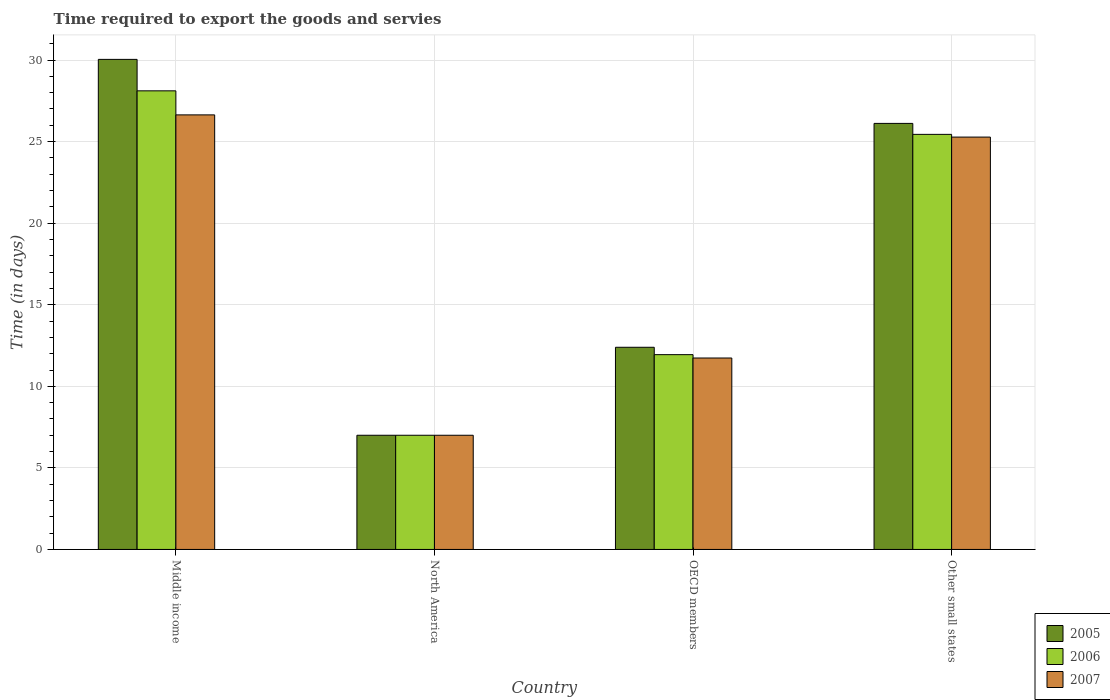Are the number of bars per tick equal to the number of legend labels?
Provide a short and direct response. Yes. How many bars are there on the 1st tick from the left?
Keep it short and to the point. 3. What is the label of the 4th group of bars from the left?
Keep it short and to the point. Other small states. In how many cases, is the number of bars for a given country not equal to the number of legend labels?
Provide a succinct answer. 0. What is the number of days required to export the goods and services in 2005 in Other small states?
Offer a very short reply. 26.12. Across all countries, what is the maximum number of days required to export the goods and services in 2007?
Provide a short and direct response. 26.64. Across all countries, what is the minimum number of days required to export the goods and services in 2005?
Keep it short and to the point. 7. In which country was the number of days required to export the goods and services in 2005 maximum?
Make the answer very short. Middle income. In which country was the number of days required to export the goods and services in 2007 minimum?
Offer a terse response. North America. What is the total number of days required to export the goods and services in 2005 in the graph?
Your answer should be compact. 75.55. What is the difference between the number of days required to export the goods and services in 2005 in Middle income and that in North America?
Give a very brief answer. 23.04. What is the difference between the number of days required to export the goods and services in 2005 in North America and the number of days required to export the goods and services in 2007 in Other small states?
Provide a short and direct response. -18.28. What is the average number of days required to export the goods and services in 2005 per country?
Provide a succinct answer. 18.89. What is the difference between the number of days required to export the goods and services of/in 2005 and number of days required to export the goods and services of/in 2007 in OECD members?
Keep it short and to the point. 0.66. What is the ratio of the number of days required to export the goods and services in 2005 in North America to that in Other small states?
Provide a succinct answer. 0.27. Is the number of days required to export the goods and services in 2007 in North America less than that in OECD members?
Provide a short and direct response. Yes. What is the difference between the highest and the second highest number of days required to export the goods and services in 2006?
Provide a succinct answer. 13.5. What is the difference between the highest and the lowest number of days required to export the goods and services in 2006?
Offer a very short reply. 21.11. What does the 3rd bar from the left in OECD members represents?
Make the answer very short. 2007. What does the 1st bar from the right in North America represents?
Your answer should be very brief. 2007. Is it the case that in every country, the sum of the number of days required to export the goods and services in 2006 and number of days required to export the goods and services in 2005 is greater than the number of days required to export the goods and services in 2007?
Offer a terse response. Yes. How many bars are there?
Offer a very short reply. 12. Are all the bars in the graph horizontal?
Your response must be concise. No. How many countries are there in the graph?
Keep it short and to the point. 4. Are the values on the major ticks of Y-axis written in scientific E-notation?
Give a very brief answer. No. What is the title of the graph?
Offer a terse response. Time required to export the goods and servies. What is the label or title of the Y-axis?
Make the answer very short. Time (in days). What is the Time (in days) in 2005 in Middle income?
Provide a short and direct response. 30.04. What is the Time (in days) in 2006 in Middle income?
Give a very brief answer. 28.11. What is the Time (in days) in 2007 in Middle income?
Offer a very short reply. 26.64. What is the Time (in days) in 2007 in North America?
Provide a short and direct response. 7. What is the Time (in days) in 2005 in OECD members?
Your answer should be very brief. 12.39. What is the Time (in days) in 2006 in OECD members?
Offer a terse response. 11.94. What is the Time (in days) of 2007 in OECD members?
Ensure brevity in your answer.  11.74. What is the Time (in days) of 2005 in Other small states?
Give a very brief answer. 26.12. What is the Time (in days) in 2006 in Other small states?
Offer a terse response. 25.44. What is the Time (in days) of 2007 in Other small states?
Your answer should be very brief. 25.28. Across all countries, what is the maximum Time (in days) in 2005?
Ensure brevity in your answer.  30.04. Across all countries, what is the maximum Time (in days) of 2006?
Your answer should be very brief. 28.11. Across all countries, what is the maximum Time (in days) in 2007?
Provide a short and direct response. 26.64. Across all countries, what is the minimum Time (in days) of 2007?
Provide a short and direct response. 7. What is the total Time (in days) in 2005 in the graph?
Give a very brief answer. 75.55. What is the total Time (in days) of 2006 in the graph?
Provide a short and direct response. 72.5. What is the total Time (in days) of 2007 in the graph?
Give a very brief answer. 70.65. What is the difference between the Time (in days) of 2005 in Middle income and that in North America?
Make the answer very short. 23.04. What is the difference between the Time (in days) in 2006 in Middle income and that in North America?
Give a very brief answer. 21.11. What is the difference between the Time (in days) of 2007 in Middle income and that in North America?
Ensure brevity in your answer.  19.64. What is the difference between the Time (in days) in 2005 in Middle income and that in OECD members?
Give a very brief answer. 17.65. What is the difference between the Time (in days) in 2006 in Middle income and that in OECD members?
Offer a very short reply. 16.17. What is the difference between the Time (in days) of 2007 in Middle income and that in OECD members?
Offer a terse response. 14.9. What is the difference between the Time (in days) of 2005 in Middle income and that in Other small states?
Your response must be concise. 3.92. What is the difference between the Time (in days) of 2006 in Middle income and that in Other small states?
Your answer should be compact. 2.67. What is the difference between the Time (in days) of 2007 in Middle income and that in Other small states?
Provide a short and direct response. 1.36. What is the difference between the Time (in days) in 2005 in North America and that in OECD members?
Ensure brevity in your answer.  -5.39. What is the difference between the Time (in days) of 2006 in North America and that in OECD members?
Offer a very short reply. -4.94. What is the difference between the Time (in days) of 2007 in North America and that in OECD members?
Ensure brevity in your answer.  -4.74. What is the difference between the Time (in days) in 2005 in North America and that in Other small states?
Your response must be concise. -19.12. What is the difference between the Time (in days) in 2006 in North America and that in Other small states?
Offer a terse response. -18.44. What is the difference between the Time (in days) in 2007 in North America and that in Other small states?
Make the answer very short. -18.28. What is the difference between the Time (in days) of 2005 in OECD members and that in Other small states?
Make the answer very short. -13.72. What is the difference between the Time (in days) in 2006 in OECD members and that in Other small states?
Ensure brevity in your answer.  -13.5. What is the difference between the Time (in days) of 2007 in OECD members and that in Other small states?
Offer a very short reply. -13.54. What is the difference between the Time (in days) of 2005 in Middle income and the Time (in days) of 2006 in North America?
Offer a very short reply. 23.04. What is the difference between the Time (in days) of 2005 in Middle income and the Time (in days) of 2007 in North America?
Your answer should be compact. 23.04. What is the difference between the Time (in days) in 2006 in Middle income and the Time (in days) in 2007 in North America?
Ensure brevity in your answer.  21.11. What is the difference between the Time (in days) in 2005 in Middle income and the Time (in days) in 2006 in OECD members?
Provide a succinct answer. 18.1. What is the difference between the Time (in days) of 2005 in Middle income and the Time (in days) of 2007 in OECD members?
Offer a very short reply. 18.31. What is the difference between the Time (in days) of 2006 in Middle income and the Time (in days) of 2007 in OECD members?
Provide a succinct answer. 16.38. What is the difference between the Time (in days) of 2005 in Middle income and the Time (in days) of 2006 in Other small states?
Provide a succinct answer. 4.6. What is the difference between the Time (in days) of 2005 in Middle income and the Time (in days) of 2007 in Other small states?
Offer a very short reply. 4.76. What is the difference between the Time (in days) of 2006 in Middle income and the Time (in days) of 2007 in Other small states?
Your response must be concise. 2.84. What is the difference between the Time (in days) of 2005 in North America and the Time (in days) of 2006 in OECD members?
Offer a very short reply. -4.94. What is the difference between the Time (in days) of 2005 in North America and the Time (in days) of 2007 in OECD members?
Give a very brief answer. -4.74. What is the difference between the Time (in days) in 2006 in North America and the Time (in days) in 2007 in OECD members?
Your answer should be very brief. -4.74. What is the difference between the Time (in days) in 2005 in North America and the Time (in days) in 2006 in Other small states?
Offer a terse response. -18.44. What is the difference between the Time (in days) of 2005 in North America and the Time (in days) of 2007 in Other small states?
Offer a very short reply. -18.28. What is the difference between the Time (in days) of 2006 in North America and the Time (in days) of 2007 in Other small states?
Your answer should be compact. -18.28. What is the difference between the Time (in days) in 2005 in OECD members and the Time (in days) in 2006 in Other small states?
Keep it short and to the point. -13.05. What is the difference between the Time (in days) of 2005 in OECD members and the Time (in days) of 2007 in Other small states?
Make the answer very short. -12.88. What is the difference between the Time (in days) of 2006 in OECD members and the Time (in days) of 2007 in Other small states?
Make the answer very short. -13.34. What is the average Time (in days) in 2005 per country?
Provide a short and direct response. 18.89. What is the average Time (in days) in 2006 per country?
Your answer should be very brief. 18.12. What is the average Time (in days) of 2007 per country?
Your response must be concise. 17.66. What is the difference between the Time (in days) of 2005 and Time (in days) of 2006 in Middle income?
Make the answer very short. 1.93. What is the difference between the Time (in days) in 2005 and Time (in days) in 2007 in Middle income?
Your answer should be compact. 3.4. What is the difference between the Time (in days) of 2006 and Time (in days) of 2007 in Middle income?
Your answer should be compact. 1.47. What is the difference between the Time (in days) of 2005 and Time (in days) of 2006 in North America?
Make the answer very short. 0. What is the difference between the Time (in days) in 2005 and Time (in days) in 2007 in North America?
Provide a short and direct response. 0. What is the difference between the Time (in days) in 2006 and Time (in days) in 2007 in North America?
Provide a succinct answer. 0. What is the difference between the Time (in days) in 2005 and Time (in days) in 2006 in OECD members?
Provide a short and direct response. 0.45. What is the difference between the Time (in days) of 2005 and Time (in days) of 2007 in OECD members?
Your response must be concise. 0.66. What is the difference between the Time (in days) in 2006 and Time (in days) in 2007 in OECD members?
Offer a terse response. 0.21. What is the difference between the Time (in days) of 2005 and Time (in days) of 2006 in Other small states?
Keep it short and to the point. 0.67. What is the difference between the Time (in days) of 2005 and Time (in days) of 2007 in Other small states?
Your response must be concise. 0.84. What is the difference between the Time (in days) of 2006 and Time (in days) of 2007 in Other small states?
Ensure brevity in your answer.  0.17. What is the ratio of the Time (in days) in 2005 in Middle income to that in North America?
Provide a short and direct response. 4.29. What is the ratio of the Time (in days) of 2006 in Middle income to that in North America?
Offer a terse response. 4.02. What is the ratio of the Time (in days) in 2007 in Middle income to that in North America?
Make the answer very short. 3.81. What is the ratio of the Time (in days) of 2005 in Middle income to that in OECD members?
Offer a very short reply. 2.42. What is the ratio of the Time (in days) in 2006 in Middle income to that in OECD members?
Give a very brief answer. 2.35. What is the ratio of the Time (in days) in 2007 in Middle income to that in OECD members?
Your answer should be compact. 2.27. What is the ratio of the Time (in days) in 2005 in Middle income to that in Other small states?
Offer a very short reply. 1.15. What is the ratio of the Time (in days) in 2006 in Middle income to that in Other small states?
Your response must be concise. 1.1. What is the ratio of the Time (in days) of 2007 in Middle income to that in Other small states?
Your answer should be compact. 1.05. What is the ratio of the Time (in days) in 2005 in North America to that in OECD members?
Ensure brevity in your answer.  0.56. What is the ratio of the Time (in days) of 2006 in North America to that in OECD members?
Offer a very short reply. 0.59. What is the ratio of the Time (in days) in 2007 in North America to that in OECD members?
Give a very brief answer. 0.6. What is the ratio of the Time (in days) in 2005 in North America to that in Other small states?
Your answer should be very brief. 0.27. What is the ratio of the Time (in days) of 2006 in North America to that in Other small states?
Offer a terse response. 0.28. What is the ratio of the Time (in days) in 2007 in North America to that in Other small states?
Your answer should be compact. 0.28. What is the ratio of the Time (in days) in 2005 in OECD members to that in Other small states?
Your answer should be very brief. 0.47. What is the ratio of the Time (in days) of 2006 in OECD members to that in Other small states?
Your response must be concise. 0.47. What is the ratio of the Time (in days) of 2007 in OECD members to that in Other small states?
Make the answer very short. 0.46. What is the difference between the highest and the second highest Time (in days) in 2005?
Your answer should be very brief. 3.92. What is the difference between the highest and the second highest Time (in days) of 2006?
Make the answer very short. 2.67. What is the difference between the highest and the second highest Time (in days) of 2007?
Give a very brief answer. 1.36. What is the difference between the highest and the lowest Time (in days) of 2005?
Offer a very short reply. 23.04. What is the difference between the highest and the lowest Time (in days) of 2006?
Give a very brief answer. 21.11. What is the difference between the highest and the lowest Time (in days) in 2007?
Your answer should be compact. 19.64. 